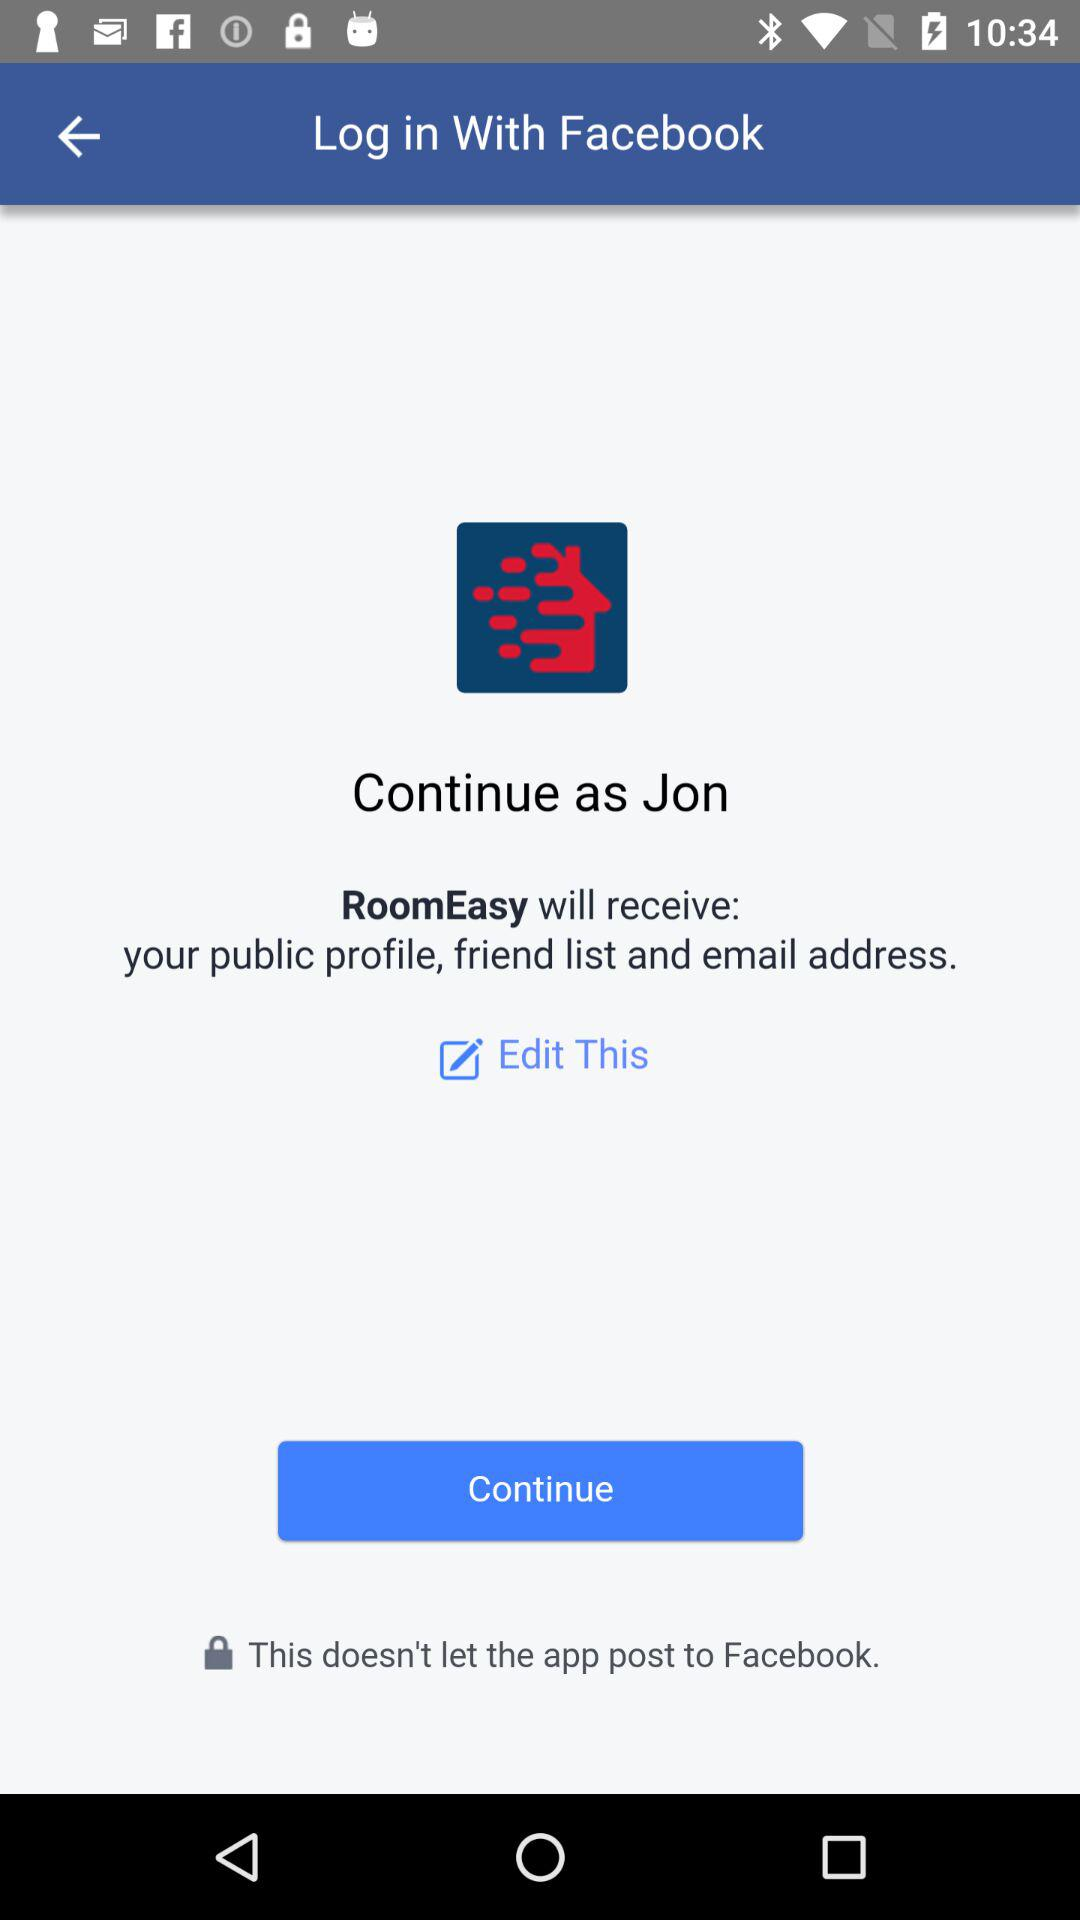What is the application name? The application name is "RoomEasy". 